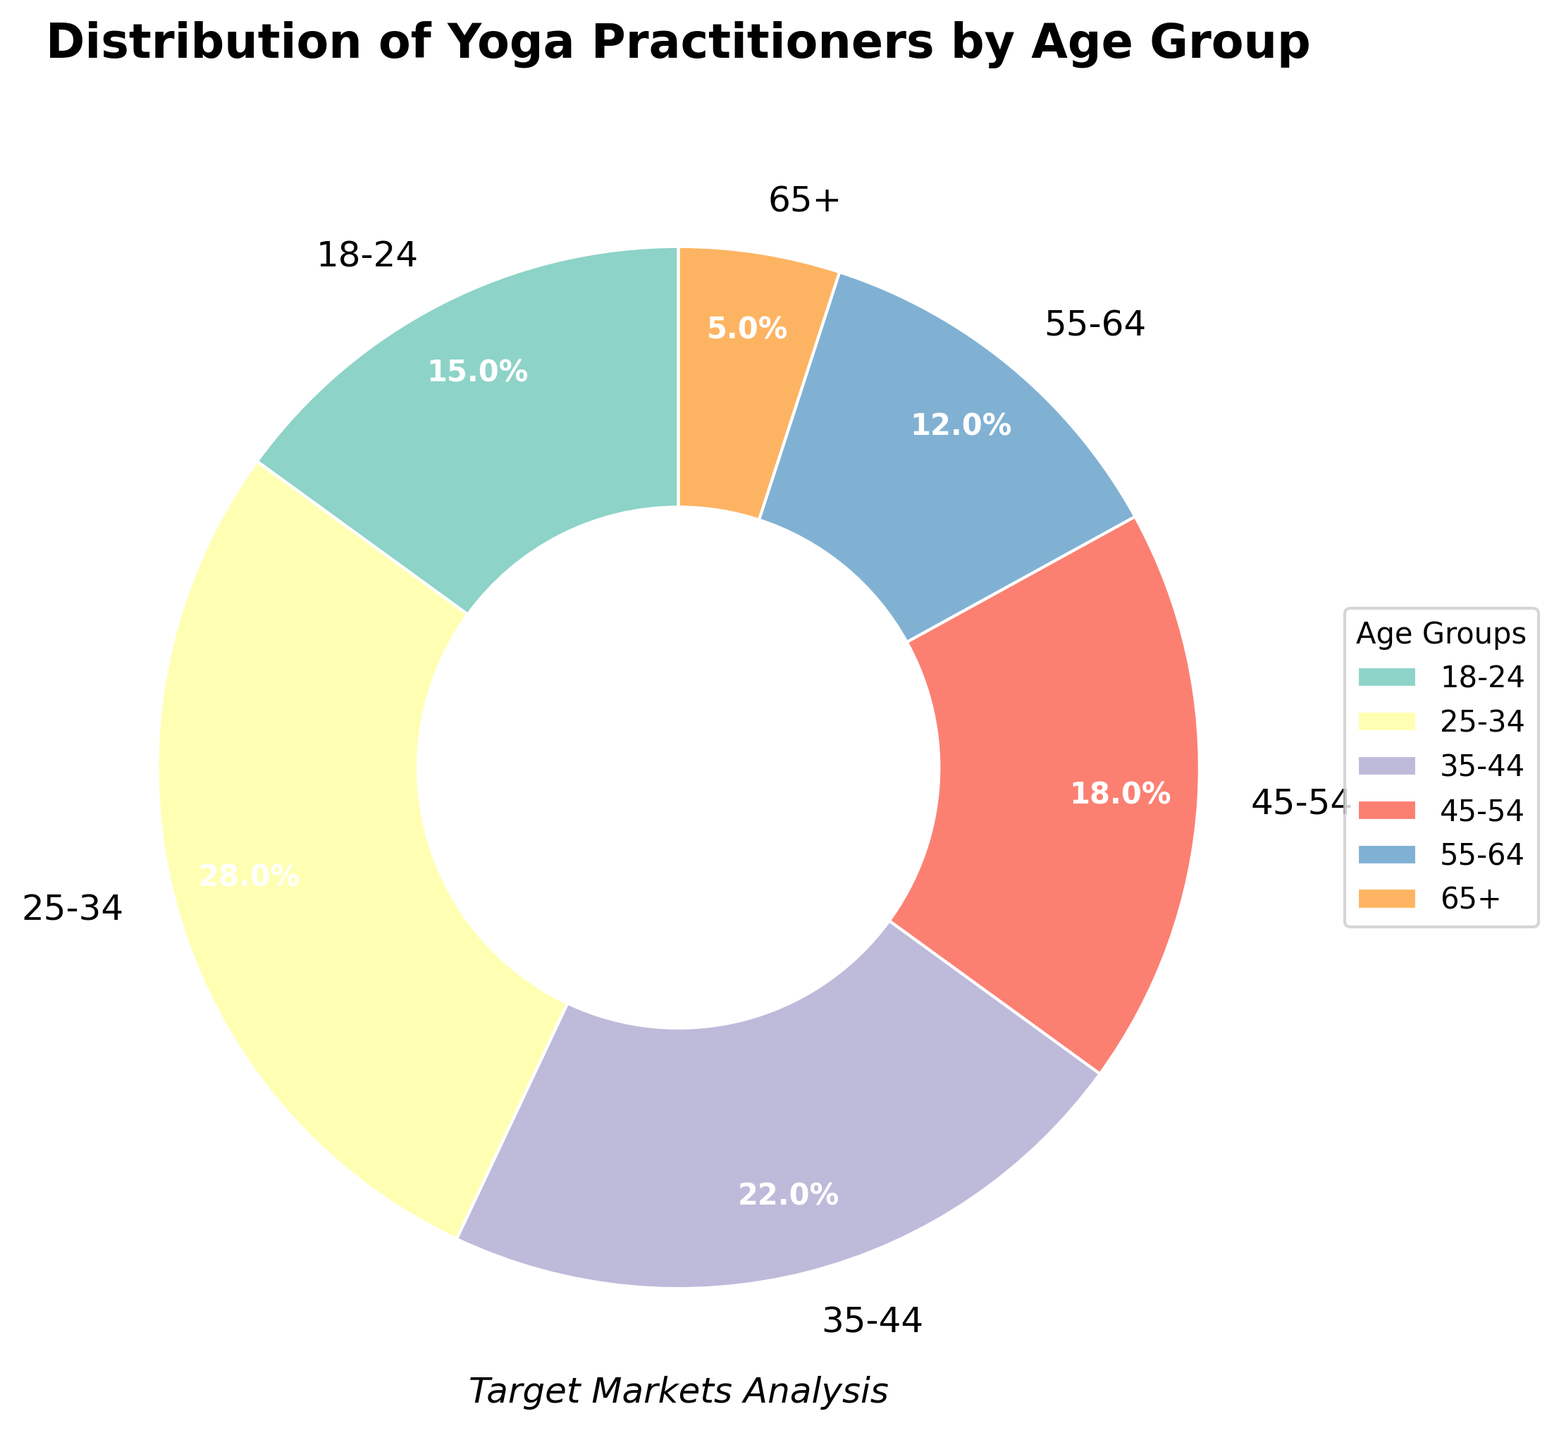What percentage of yoga practitioners are aged 25-34? From the pie chart, the slice labelled "25-34" represents 28% of the yoga practitioners.
Answer: 28% Which age group has the highest percentage of yoga practitioners? By observing the largest slice in the pie chart, it's evident that the age group 25-34 has the highest percentage.
Answer: 25-34 What is the combined percentage of yoga practitioners aged 45-54 and 55-64? The slices labelled "45-54" and "55-64" on the pie chart represent 18% and 12% respectively. Adding these values gives 18% + 12% = 30%.
Answer: 30% How does the percentage of yoga practitioners aged 18-24 compare to those aged 65+? The pie chart shows that 15% of yoga practitioners are aged 18-24, while 5% are aged 65+. Therefore, the percentage of those aged 18-24 is greater.
Answer: Greater What is the difference in percentage between the two largest age groups of yoga practitioners? The two largest age groups are 25-34 and 35-44, representing 28% and 22% respectively. The difference is 28% - 22% = 6%.
Answer: 6% Which two age groups combined have the smallest percentage of yoga practitioners? From the pie chart, the age groups 65+ (5%) and 55-64 (12%) have the smallest individual percentages. Summing these, we get 5% + 12% = 17%.
Answer: 65+ and 55-64 What is the total percentage of yoga practitioners aged under 35? The pie chart indicates that the percentages for the age groups 18-24 and 25-34 are 15% and 28% respectively. Adding these gives 15% + 28% = 43%.
Answer: 43% Which color represents the age group 35-44 on the pie chart, and what is its corresponding percentage? The pie chart shows that the age group 35-44 is represented by a specific color (identify the color used in the figure, e.g., purple), and it constitutes 22% of the yoga practitioners.
Answer: Purple, 22% Among the age groups 25-34, 35-44, and 45-54, which one has the lowest percentage of yoga practitioners? The pie chart shows the percentages for these age groups as 28%, 22%, and 18% respectively. The lowest percentage among these is 18%, corresponding to the age group 45-54.
Answer: 45-54 What percentage of yoga practitioners are aged 35 or older? The relevant age groups on the pie chart are 35-44 (22%), 45-54 (18%), 55-64 (12%), and 65+ (5%). Adding these gives 22% + 18% + 12% + 5% = 57%.
Answer: 57% 